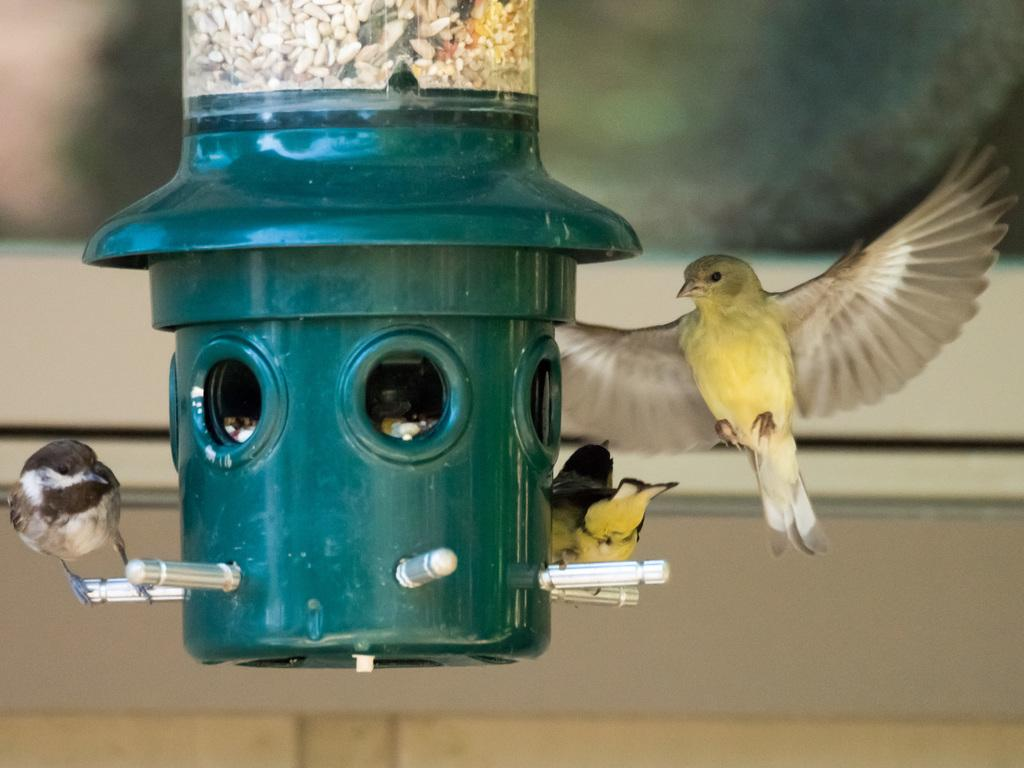What is the primary subject of the image? There are many birds in the image. Can you describe any other objects or structures in the image? There is a green pole in the image, and it has holes. Is there any additional context or support for the green pole? Yes, there is a stand associated with the green pole. What type of meal is being served on the green pole in the image? There is no meal being served on the green pole in the image; it is a pole with holes and a stand. 